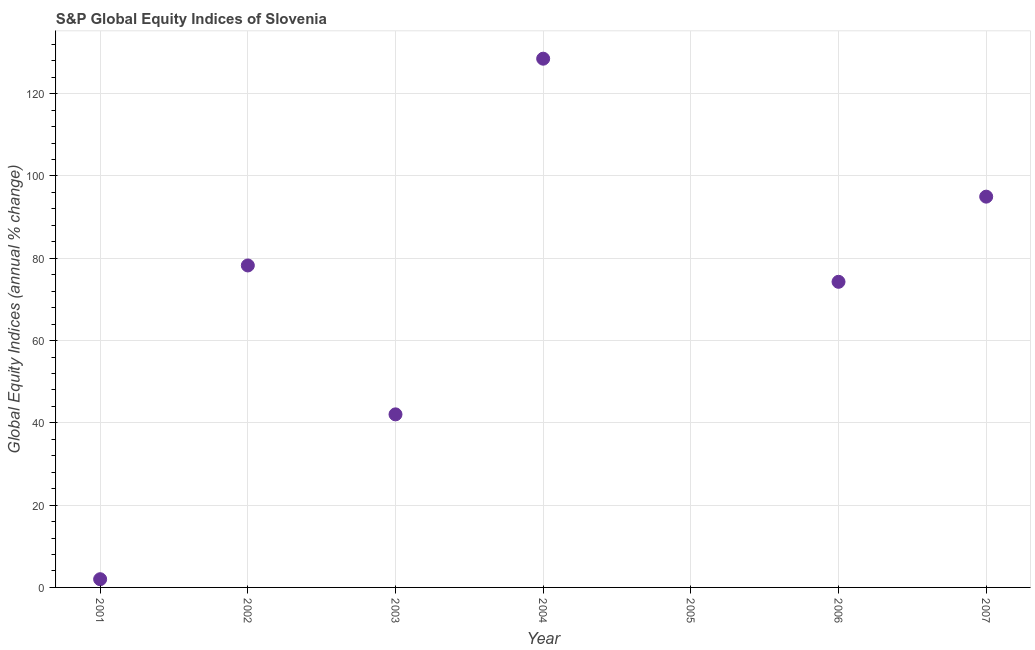What is the s&p global equity indices in 2004?
Give a very brief answer. 128.5. Across all years, what is the maximum s&p global equity indices?
Give a very brief answer. 128.5. What is the sum of the s&p global equity indices?
Your response must be concise. 420.05. What is the difference between the s&p global equity indices in 2001 and 2006?
Provide a short and direct response. -72.28. What is the average s&p global equity indices per year?
Keep it short and to the point. 60.01. What is the median s&p global equity indices?
Your response must be concise. 74.27. What is the ratio of the s&p global equity indices in 2002 to that in 2003?
Your answer should be very brief. 1.86. Is the s&p global equity indices in 2001 less than that in 2007?
Offer a terse response. Yes. What is the difference between the highest and the second highest s&p global equity indices?
Keep it short and to the point. 33.53. Is the sum of the s&p global equity indices in 2001 and 2002 greater than the maximum s&p global equity indices across all years?
Offer a very short reply. No. What is the difference between the highest and the lowest s&p global equity indices?
Offer a terse response. 128.5. How many dotlines are there?
Ensure brevity in your answer.  1. How many years are there in the graph?
Keep it short and to the point. 7. What is the difference between two consecutive major ticks on the Y-axis?
Ensure brevity in your answer.  20. What is the title of the graph?
Give a very brief answer. S&P Global Equity Indices of Slovenia. What is the label or title of the Y-axis?
Your response must be concise. Global Equity Indices (annual % change). What is the Global Equity Indices (annual % change) in 2001?
Your answer should be compact. 2. What is the Global Equity Indices (annual % change) in 2002?
Give a very brief answer. 78.25. What is the Global Equity Indices (annual % change) in 2003?
Offer a very short reply. 42.06. What is the Global Equity Indices (annual % change) in 2004?
Your answer should be very brief. 128.5. What is the Global Equity Indices (annual % change) in 2005?
Offer a very short reply. 0. What is the Global Equity Indices (annual % change) in 2006?
Make the answer very short. 74.27. What is the Global Equity Indices (annual % change) in 2007?
Keep it short and to the point. 94.97. What is the difference between the Global Equity Indices (annual % change) in 2001 and 2002?
Offer a terse response. -76.25. What is the difference between the Global Equity Indices (annual % change) in 2001 and 2003?
Offer a terse response. -40.06. What is the difference between the Global Equity Indices (annual % change) in 2001 and 2004?
Your answer should be very brief. -126.5. What is the difference between the Global Equity Indices (annual % change) in 2001 and 2006?
Offer a terse response. -72.28. What is the difference between the Global Equity Indices (annual % change) in 2001 and 2007?
Keep it short and to the point. -92.97. What is the difference between the Global Equity Indices (annual % change) in 2002 and 2003?
Your response must be concise. 36.19. What is the difference between the Global Equity Indices (annual % change) in 2002 and 2004?
Offer a very short reply. -50.25. What is the difference between the Global Equity Indices (annual % change) in 2002 and 2006?
Make the answer very short. 3.98. What is the difference between the Global Equity Indices (annual % change) in 2002 and 2007?
Provide a short and direct response. -16.72. What is the difference between the Global Equity Indices (annual % change) in 2003 and 2004?
Your answer should be compact. -86.44. What is the difference between the Global Equity Indices (annual % change) in 2003 and 2006?
Your answer should be compact. -32.21. What is the difference between the Global Equity Indices (annual % change) in 2003 and 2007?
Your answer should be very brief. -52.91. What is the difference between the Global Equity Indices (annual % change) in 2004 and 2006?
Give a very brief answer. 54.23. What is the difference between the Global Equity Indices (annual % change) in 2004 and 2007?
Give a very brief answer. 33.53. What is the difference between the Global Equity Indices (annual % change) in 2006 and 2007?
Your answer should be very brief. -20.7. What is the ratio of the Global Equity Indices (annual % change) in 2001 to that in 2002?
Offer a terse response. 0.03. What is the ratio of the Global Equity Indices (annual % change) in 2001 to that in 2003?
Your response must be concise. 0.05. What is the ratio of the Global Equity Indices (annual % change) in 2001 to that in 2004?
Offer a terse response. 0.02. What is the ratio of the Global Equity Indices (annual % change) in 2001 to that in 2006?
Your response must be concise. 0.03. What is the ratio of the Global Equity Indices (annual % change) in 2001 to that in 2007?
Give a very brief answer. 0.02. What is the ratio of the Global Equity Indices (annual % change) in 2002 to that in 2003?
Your answer should be compact. 1.86. What is the ratio of the Global Equity Indices (annual % change) in 2002 to that in 2004?
Your answer should be compact. 0.61. What is the ratio of the Global Equity Indices (annual % change) in 2002 to that in 2006?
Keep it short and to the point. 1.05. What is the ratio of the Global Equity Indices (annual % change) in 2002 to that in 2007?
Provide a short and direct response. 0.82. What is the ratio of the Global Equity Indices (annual % change) in 2003 to that in 2004?
Your answer should be very brief. 0.33. What is the ratio of the Global Equity Indices (annual % change) in 2003 to that in 2006?
Your answer should be very brief. 0.57. What is the ratio of the Global Equity Indices (annual % change) in 2003 to that in 2007?
Provide a short and direct response. 0.44. What is the ratio of the Global Equity Indices (annual % change) in 2004 to that in 2006?
Offer a very short reply. 1.73. What is the ratio of the Global Equity Indices (annual % change) in 2004 to that in 2007?
Provide a succinct answer. 1.35. What is the ratio of the Global Equity Indices (annual % change) in 2006 to that in 2007?
Offer a terse response. 0.78. 